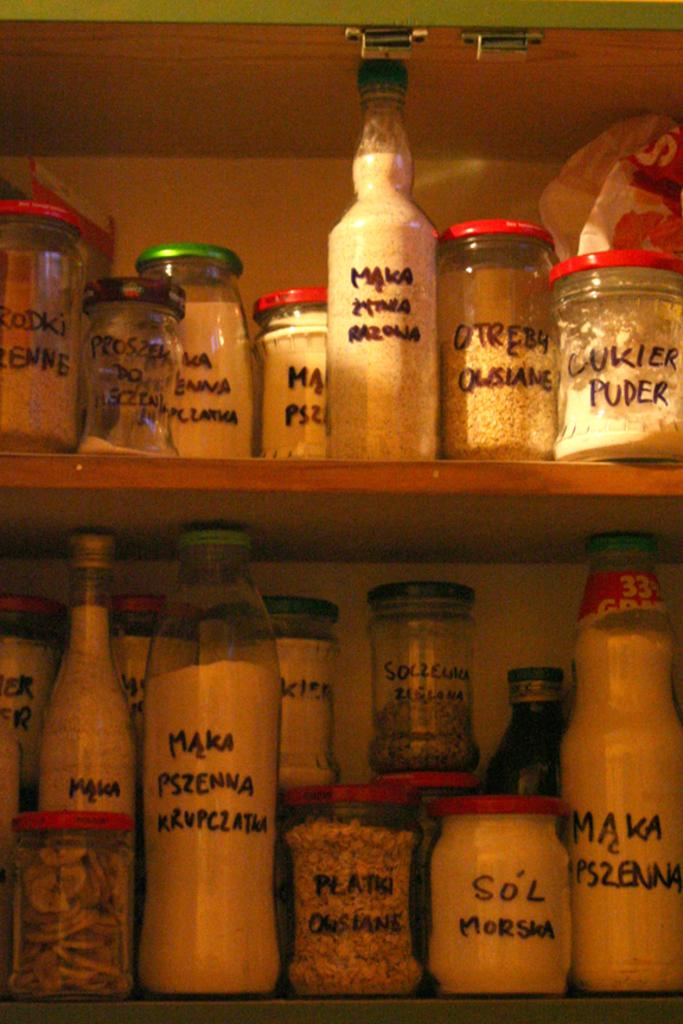<image>
Share a concise interpretation of the image provided. Several containers of food items with labels like "cukier puder" 